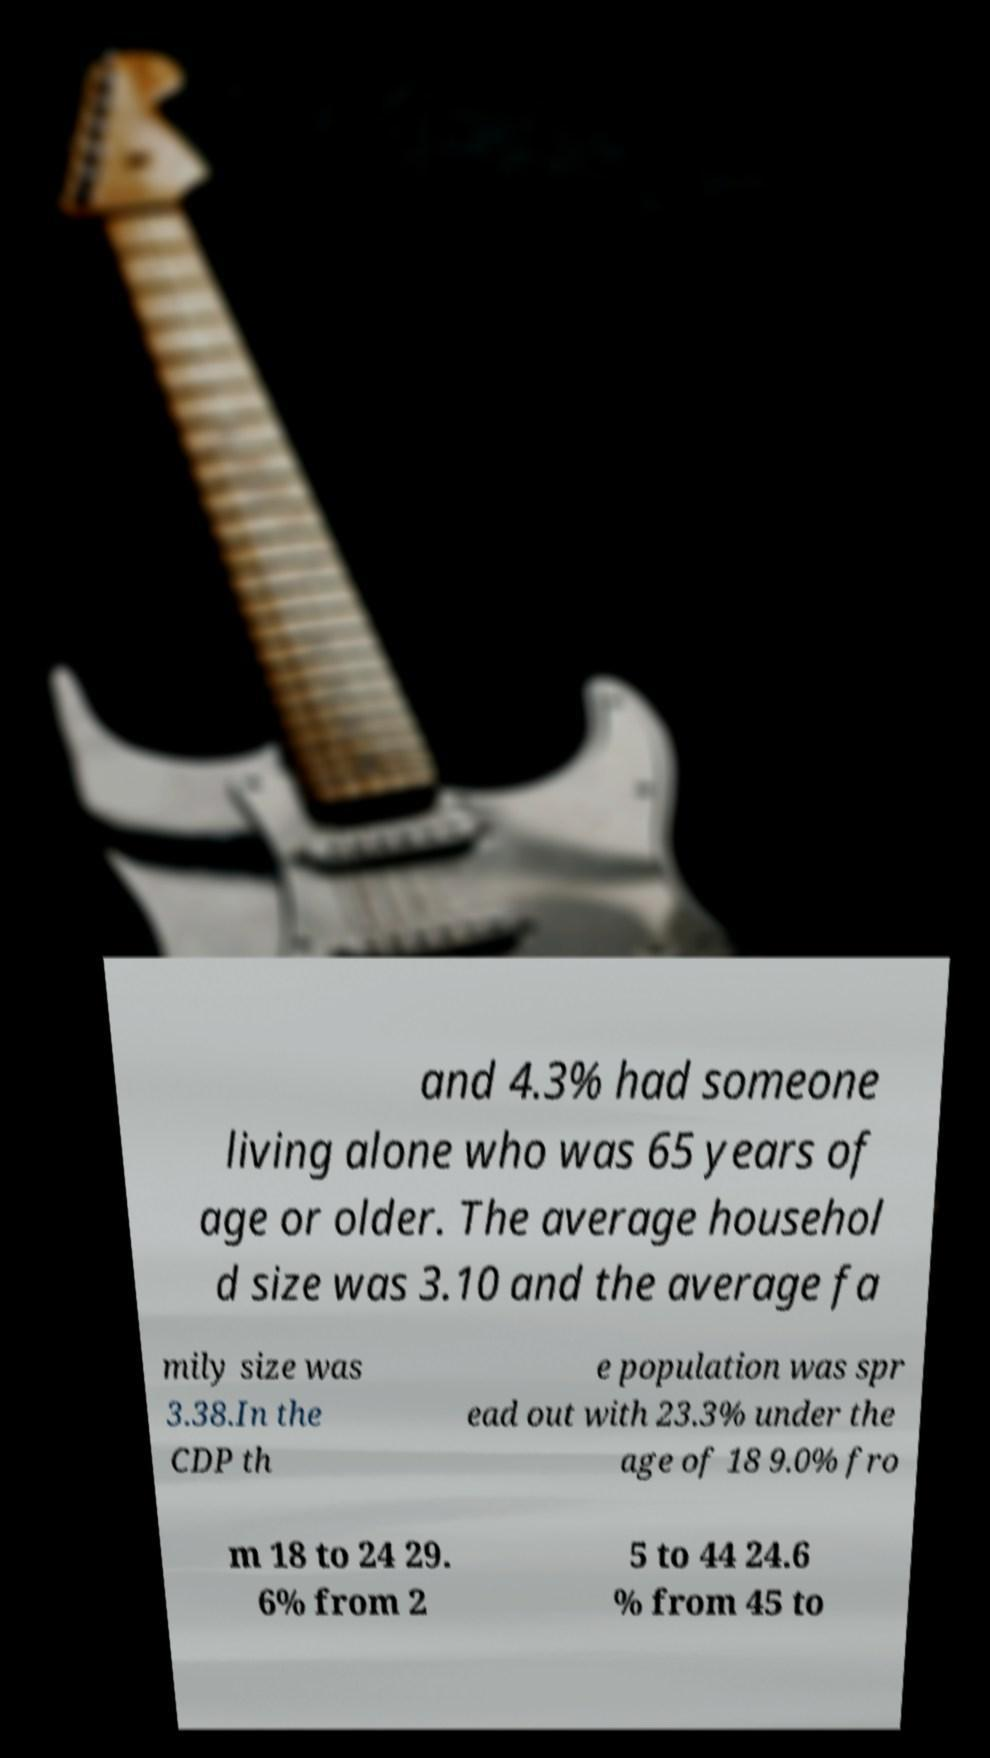What messages or text are displayed in this image? I need them in a readable, typed format. and 4.3% had someone living alone who was 65 years of age or older. The average househol d size was 3.10 and the average fa mily size was 3.38.In the CDP th e population was spr ead out with 23.3% under the age of 18 9.0% fro m 18 to 24 29. 6% from 2 5 to 44 24.6 % from 45 to 